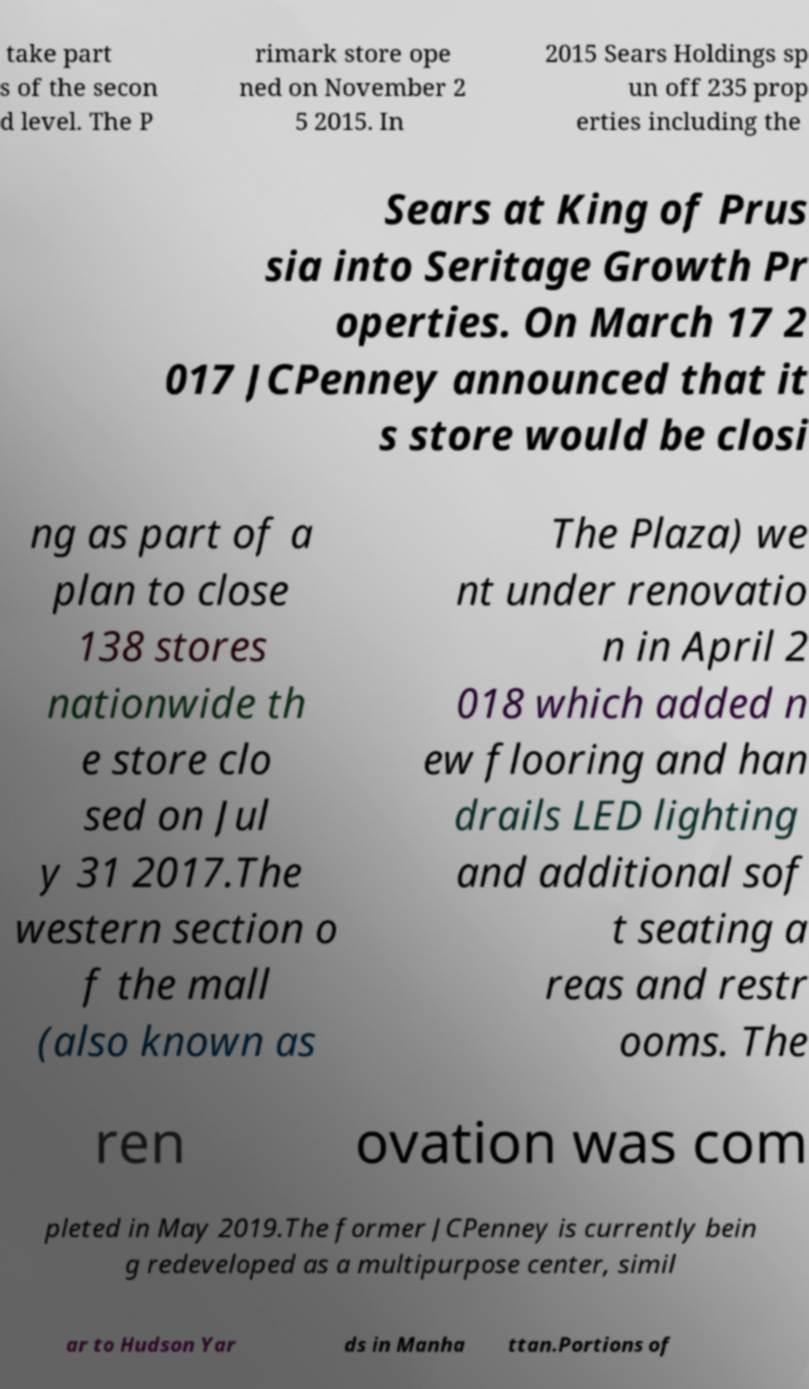I need the written content from this picture converted into text. Can you do that? take part s of the secon d level. The P rimark store ope ned on November 2 5 2015. In 2015 Sears Holdings sp un off 235 prop erties including the Sears at King of Prus sia into Seritage Growth Pr operties. On March 17 2 017 JCPenney announced that it s store would be closi ng as part of a plan to close 138 stores nationwide th e store clo sed on Jul y 31 2017.The western section o f the mall (also known as The Plaza) we nt under renovatio n in April 2 018 which added n ew flooring and han drails LED lighting and additional sof t seating a reas and restr ooms. The ren ovation was com pleted in May 2019.The former JCPenney is currently bein g redeveloped as a multipurpose center, simil ar to Hudson Yar ds in Manha ttan.Portions of 